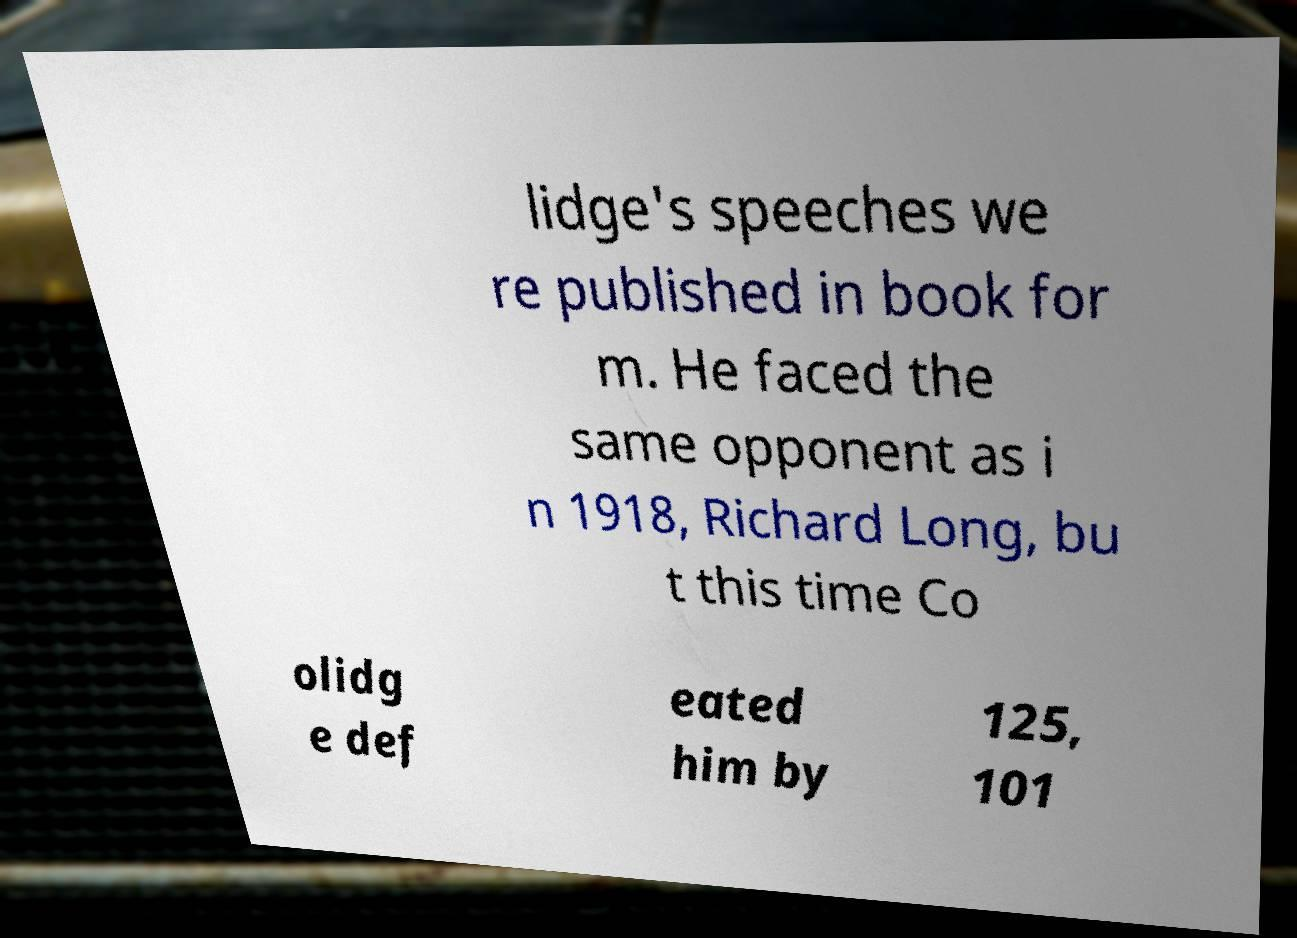For documentation purposes, I need the text within this image transcribed. Could you provide that? lidge's speeches we re published in book for m. He faced the same opponent as i n 1918, Richard Long, bu t this time Co olidg e def eated him by 125, 101 